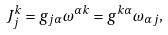Convert formula to latex. <formula><loc_0><loc_0><loc_500><loc_500>J _ { j } ^ { k } = g _ { j \alpha } \omega ^ { \alpha k } = g ^ { k \alpha } \omega _ { \alpha j } ,</formula> 